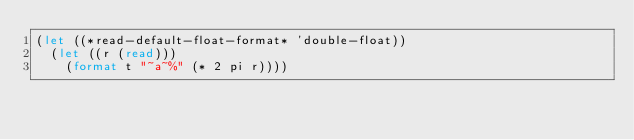<code> <loc_0><loc_0><loc_500><loc_500><_Lisp_>(let ((*read-default-float-format* 'double-float))
  (let ((r (read)))
    (format t "~a~%" (* 2 pi r))))
</code> 